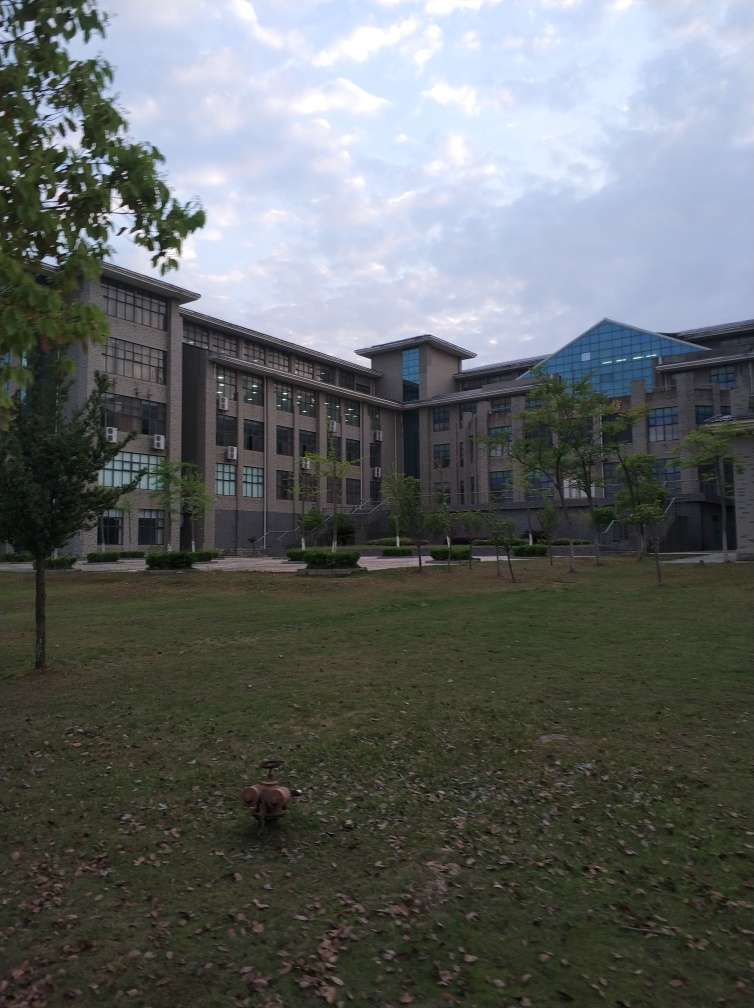Can you describe the architecture of the buildings in the background? The buildings in the background have a modern architectural style, with a symmetrical layout and large windows. The structures feature a mix of rectangular forms, and the facade appears to be made of materials like glass and possibly stone or concrete. The roofing has a slight pitch and includes what looks to be skylights or glass paneling. 